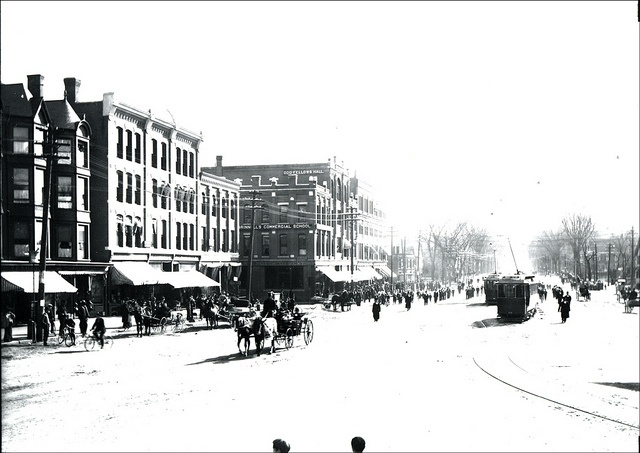Describe the objects in this image and their specific colors. I can see people in black, white, gray, and darkgray tones, train in black, white, gray, and darkgray tones, horse in black, white, gray, and darkgray tones, horse in black, white, gray, and darkgray tones, and horse in black, white, gray, and darkgray tones in this image. 